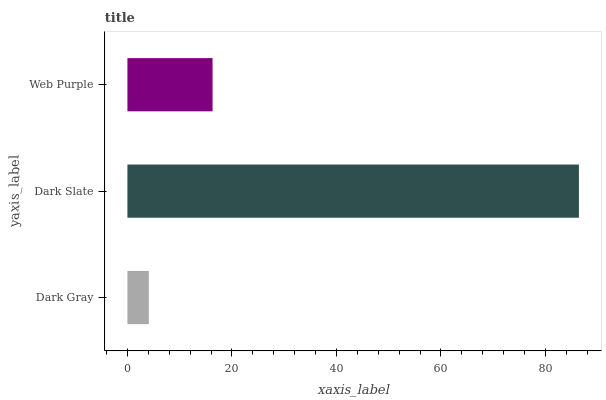Is Dark Gray the minimum?
Answer yes or no. Yes. Is Dark Slate the maximum?
Answer yes or no. Yes. Is Web Purple the minimum?
Answer yes or no. No. Is Web Purple the maximum?
Answer yes or no. No. Is Dark Slate greater than Web Purple?
Answer yes or no. Yes. Is Web Purple less than Dark Slate?
Answer yes or no. Yes. Is Web Purple greater than Dark Slate?
Answer yes or no. No. Is Dark Slate less than Web Purple?
Answer yes or no. No. Is Web Purple the high median?
Answer yes or no. Yes. Is Web Purple the low median?
Answer yes or no. Yes. Is Dark Gray the high median?
Answer yes or no. No. Is Dark Slate the low median?
Answer yes or no. No. 